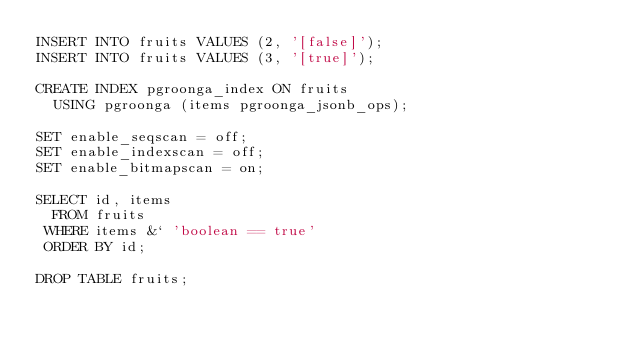Convert code to text. <code><loc_0><loc_0><loc_500><loc_500><_SQL_>INSERT INTO fruits VALUES (2, '[false]');
INSERT INTO fruits VALUES (3, '[true]');

CREATE INDEX pgroonga_index ON fruits
  USING pgroonga (items pgroonga_jsonb_ops);

SET enable_seqscan = off;
SET enable_indexscan = off;
SET enable_bitmapscan = on;

SELECT id, items
  FROM fruits
 WHERE items &` 'boolean == true'
 ORDER BY id;

DROP TABLE fruits;
</code> 